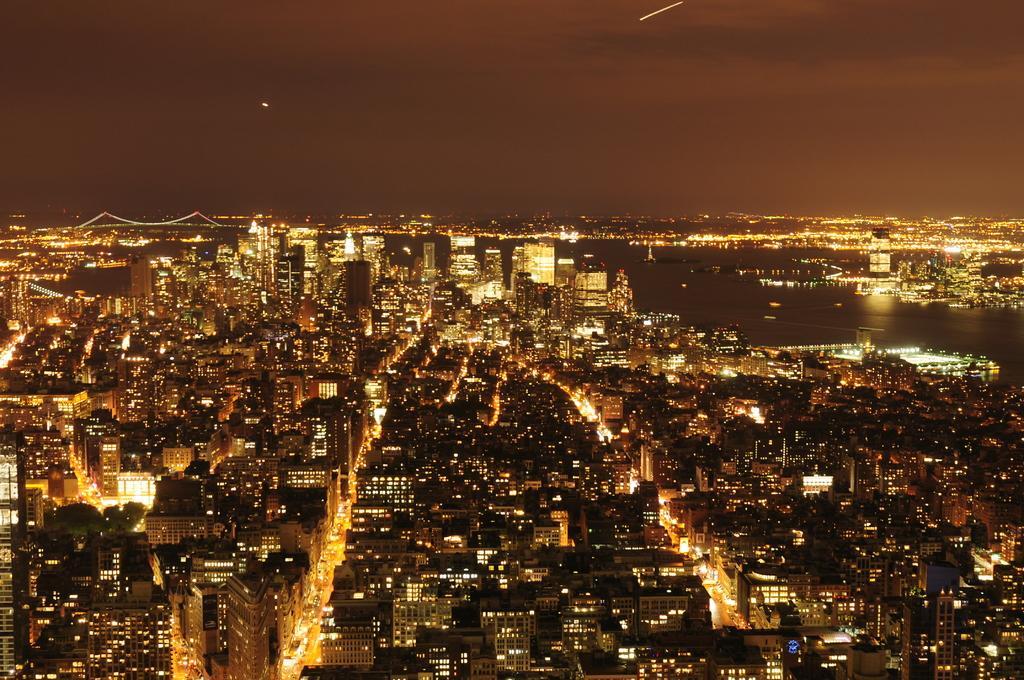In one or two sentences, can you explain what this image depicts? In this image we can see many buildings with lights. Also there are trees. On the right side there is water. In the back there is a bridge and sky. 